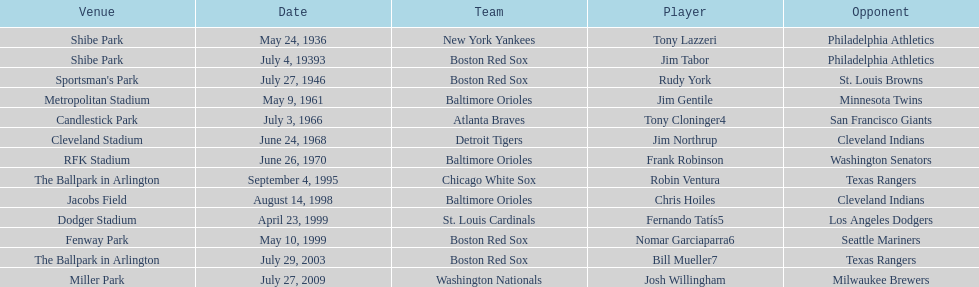Which major league batter was the first to hit two grand slams during a single game? Tony Lazzeri. 